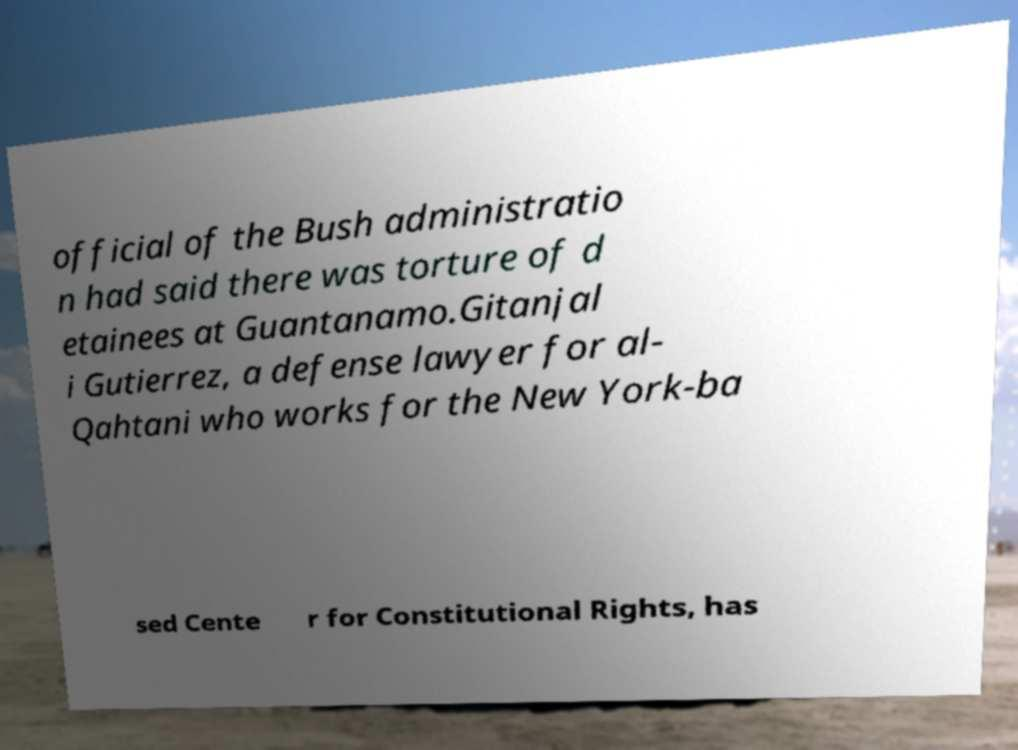Could you assist in decoding the text presented in this image and type it out clearly? official of the Bush administratio n had said there was torture of d etainees at Guantanamo.Gitanjal i Gutierrez, a defense lawyer for al- Qahtani who works for the New York-ba sed Cente r for Constitutional Rights, has 